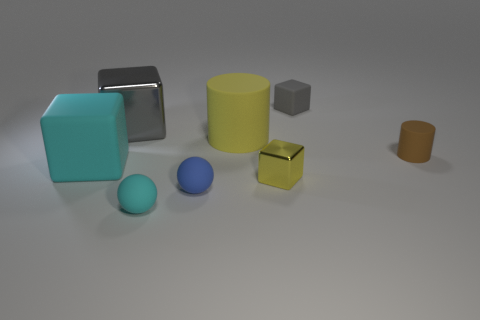How many objects are either tiny matte things that are behind the large gray metallic block or big red metallic objects?
Offer a terse response. 1. The rubber object that is to the left of the cyan matte thing to the right of the large block that is in front of the big yellow rubber cylinder is what color?
Make the answer very short. Cyan. What color is the small cylinder that is made of the same material as the small gray thing?
Offer a very short reply. Brown. What number of cubes are the same material as the tiny cyan ball?
Keep it short and to the point. 2. Do the gray block that is left of the blue rubber thing and the tiny yellow block have the same size?
Keep it short and to the point. No. There is a shiny thing that is the same size as the brown matte object; what color is it?
Ensure brevity in your answer.  Yellow. How many blocks are right of the yellow rubber object?
Make the answer very short. 2. Is there a small blue rubber cylinder?
Ensure brevity in your answer.  No. There is a yellow thing left of the tiny cube in front of the large cube in front of the large yellow cylinder; what size is it?
Keep it short and to the point. Large. What number of other objects are the same size as the gray shiny object?
Ensure brevity in your answer.  2. 